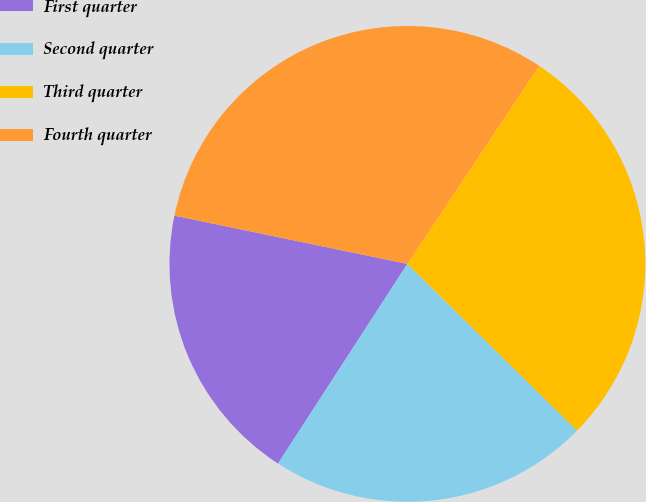<chart> <loc_0><loc_0><loc_500><loc_500><pie_chart><fcel>First quarter<fcel>Second quarter<fcel>Third quarter<fcel>Fourth quarter<nl><fcel>19.1%<fcel>21.79%<fcel>28.02%<fcel>31.09%<nl></chart> 